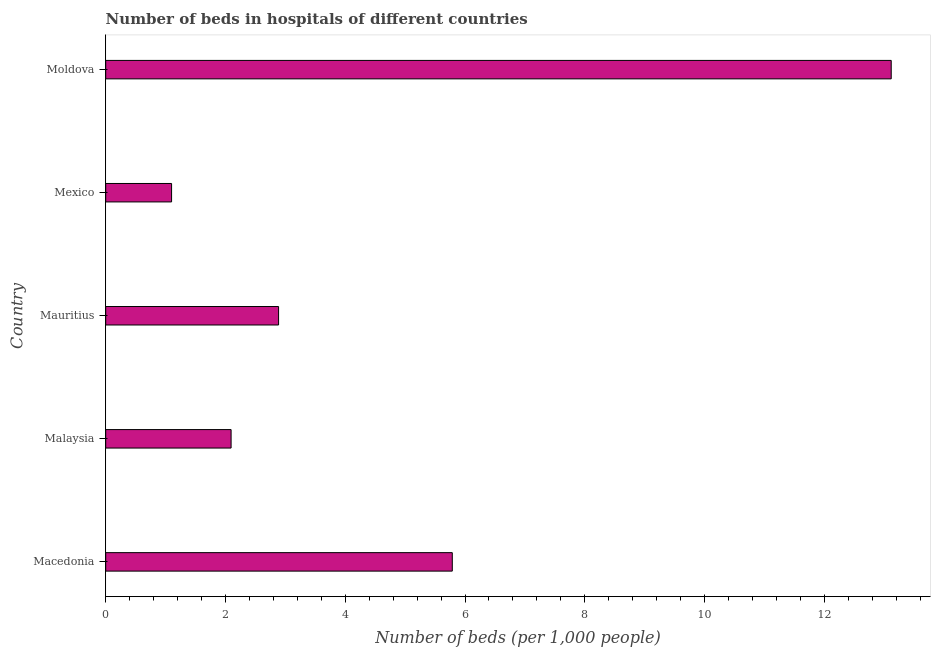Does the graph contain grids?
Your answer should be very brief. No. What is the title of the graph?
Offer a very short reply. Number of beds in hospitals of different countries. What is the label or title of the X-axis?
Keep it short and to the point. Number of beds (per 1,0 people). What is the label or title of the Y-axis?
Keep it short and to the point. Country. What is the number of hospital beds in Macedonia?
Ensure brevity in your answer.  5.79. Across all countries, what is the maximum number of hospital beds?
Offer a very short reply. 13.12. Across all countries, what is the minimum number of hospital beds?
Ensure brevity in your answer.  1.1. In which country was the number of hospital beds maximum?
Make the answer very short. Moldova. What is the sum of the number of hospital beds?
Give a very brief answer. 24.98. What is the difference between the number of hospital beds in Mauritius and Mexico?
Offer a very short reply. 1.79. What is the average number of hospital beds per country?
Make the answer very short. 5. What is the median number of hospital beds?
Your response must be concise. 2.89. In how many countries, is the number of hospital beds greater than 1.2 %?
Make the answer very short. 4. What is the ratio of the number of hospital beds in Malaysia to that in Mexico?
Your answer should be compact. 1.9. Is the number of hospital beds in Macedonia less than that in Mexico?
Your answer should be very brief. No. Is the difference between the number of hospital beds in Malaysia and Moldova greater than the difference between any two countries?
Provide a short and direct response. No. What is the difference between the highest and the second highest number of hospital beds?
Ensure brevity in your answer.  7.33. Is the sum of the number of hospital beds in Mexico and Moldova greater than the maximum number of hospital beds across all countries?
Offer a terse response. Yes. What is the difference between the highest and the lowest number of hospital beds?
Make the answer very short. 12.02. In how many countries, is the number of hospital beds greater than the average number of hospital beds taken over all countries?
Your response must be concise. 2. How many bars are there?
Ensure brevity in your answer.  5. What is the difference between two consecutive major ticks on the X-axis?
Offer a terse response. 2. Are the values on the major ticks of X-axis written in scientific E-notation?
Provide a succinct answer. No. What is the Number of beds (per 1,000 people) of Macedonia?
Provide a short and direct response. 5.79. What is the Number of beds (per 1,000 people) of Malaysia?
Provide a succinct answer. 2.09. What is the Number of beds (per 1,000 people) of Mauritius?
Offer a very short reply. 2.89. What is the Number of beds (per 1,000 people) in Mexico?
Provide a succinct answer. 1.1. What is the Number of beds (per 1,000 people) in Moldova?
Keep it short and to the point. 13.12. What is the difference between the Number of beds (per 1,000 people) in Macedonia and Malaysia?
Offer a very short reply. 3.69. What is the difference between the Number of beds (per 1,000 people) in Macedonia and Mauritius?
Give a very brief answer. 2.9. What is the difference between the Number of beds (per 1,000 people) in Macedonia and Mexico?
Offer a terse response. 4.69. What is the difference between the Number of beds (per 1,000 people) in Macedonia and Moldova?
Offer a very short reply. -7.33. What is the difference between the Number of beds (per 1,000 people) in Malaysia and Mauritius?
Offer a terse response. -0.79. What is the difference between the Number of beds (per 1,000 people) in Malaysia and Mexico?
Make the answer very short. 0.99. What is the difference between the Number of beds (per 1,000 people) in Malaysia and Moldova?
Keep it short and to the point. -11.02. What is the difference between the Number of beds (per 1,000 people) in Mauritius and Mexico?
Make the answer very short. 1.79. What is the difference between the Number of beds (per 1,000 people) in Mauritius and Moldova?
Your answer should be compact. -10.23. What is the difference between the Number of beds (per 1,000 people) in Mexico and Moldova?
Your response must be concise. -12.02. What is the ratio of the Number of beds (per 1,000 people) in Macedonia to that in Malaysia?
Give a very brief answer. 2.76. What is the ratio of the Number of beds (per 1,000 people) in Macedonia to that in Mauritius?
Keep it short and to the point. 2. What is the ratio of the Number of beds (per 1,000 people) in Macedonia to that in Mexico?
Your answer should be compact. 5.26. What is the ratio of the Number of beds (per 1,000 people) in Macedonia to that in Moldova?
Offer a very short reply. 0.44. What is the ratio of the Number of beds (per 1,000 people) in Malaysia to that in Mauritius?
Ensure brevity in your answer.  0.72. What is the ratio of the Number of beds (per 1,000 people) in Malaysia to that in Mexico?
Make the answer very short. 1.9. What is the ratio of the Number of beds (per 1,000 people) in Malaysia to that in Moldova?
Give a very brief answer. 0.16. What is the ratio of the Number of beds (per 1,000 people) in Mauritius to that in Mexico?
Your answer should be compact. 2.62. What is the ratio of the Number of beds (per 1,000 people) in Mauritius to that in Moldova?
Offer a very short reply. 0.22. What is the ratio of the Number of beds (per 1,000 people) in Mexico to that in Moldova?
Provide a short and direct response. 0.08. 